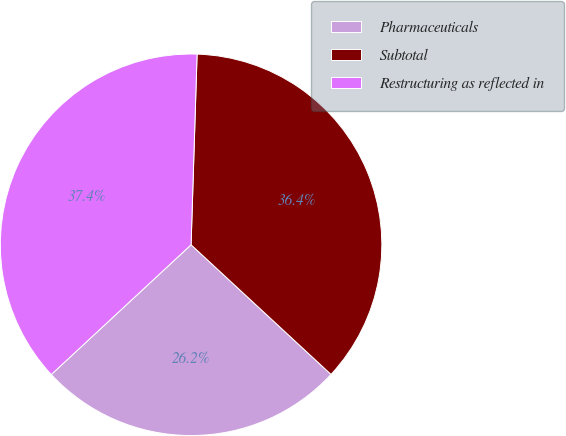Convert chart. <chart><loc_0><loc_0><loc_500><loc_500><pie_chart><fcel>Pharmaceuticals<fcel>Subtotal<fcel>Restructuring as reflected in<nl><fcel>26.2%<fcel>36.39%<fcel>37.41%<nl></chart> 